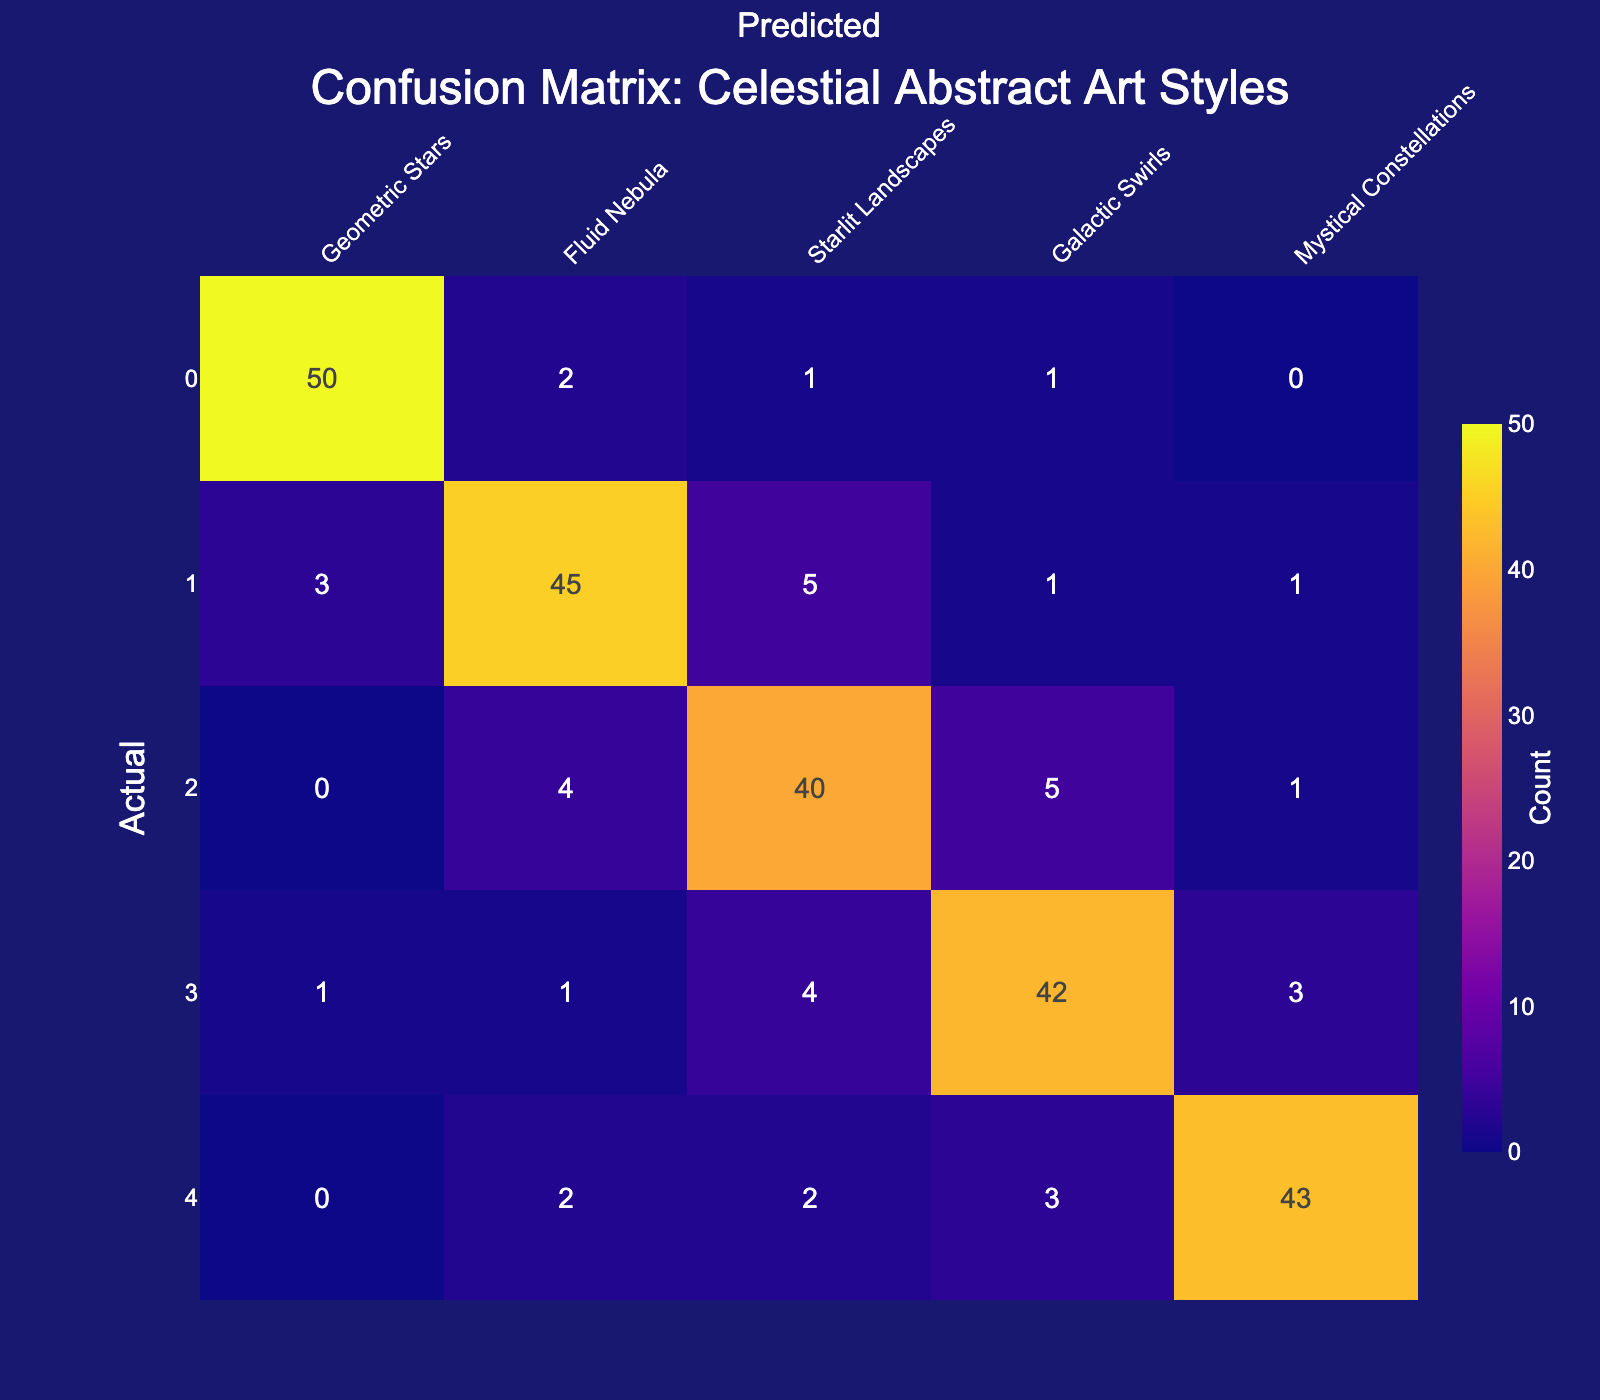What is the number of customers who prefer "Geometric Stars" and were correctly classified? The number of customers who prefer "Geometric Stars" and were correctly classified is found on the diagonal of the confusion matrix. Looking at the row for "Geometric Stars" and the column for "Geometric Stars," we see the value is 50.
Answer: 50 What is the total number of customers who prefer "Fluid Nebula"? To find the total number of customers who prefer "Fluid Nebula," we sum all the values in the row for "Fluid Nebula." This includes: 3 + 45 + 5 + 1 + 1 = 55.
Answer: 55 Is the prediction for "Galactic Swirls" more accurate than for "Starlit Landscapes"? To determine this, we compare the correctly classified values for "Galactic Swirls" (42) and "Starlit Landscapes" (40). Since 42 is greater than 40, the prediction for "Galactic Swirls" is indeed more accurate.
Answer: Yes What is the sum of the misclassifications for "Mystical Constellations"? The misclassifications for "Mystical Constellations" can be summed up by adding the values in the row for "Mystical Constellations" that are not on the diagonal. This includes: 2 + 2 + 3 = 7.
Answer: 7 What percentage of customers who prefer "Starlit Landscapes" were correctly classified? To find the percentage of customers who were correctly classified as "Starlit Landscapes," we take the value on the diagonal (40), divide it by the total of that row (0 + 4 + 40 + 5 + 1 = 50), and multiply by 100. This gives us (40/50) * 100 = 80%.
Answer: 80% 